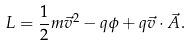Convert formula to latex. <formula><loc_0><loc_0><loc_500><loc_500>L = \frac { 1 } { 2 } m \vec { v } ^ { 2 } - q \phi + q \vec { v } \cdot \vec { A } .</formula> 